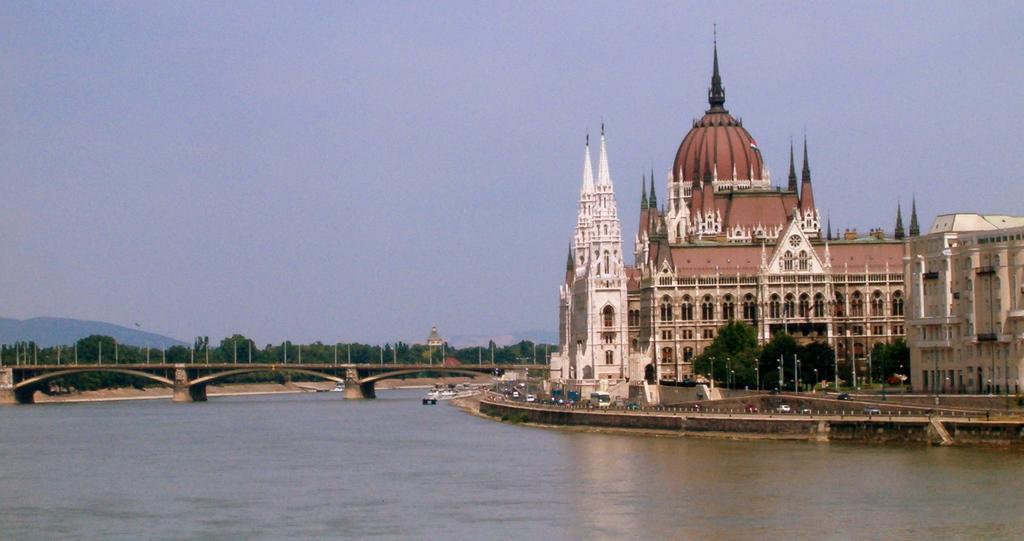Can you describe this image briefly? In the right side there are buildings and trees, this is water, In this left side it is a bridge. 